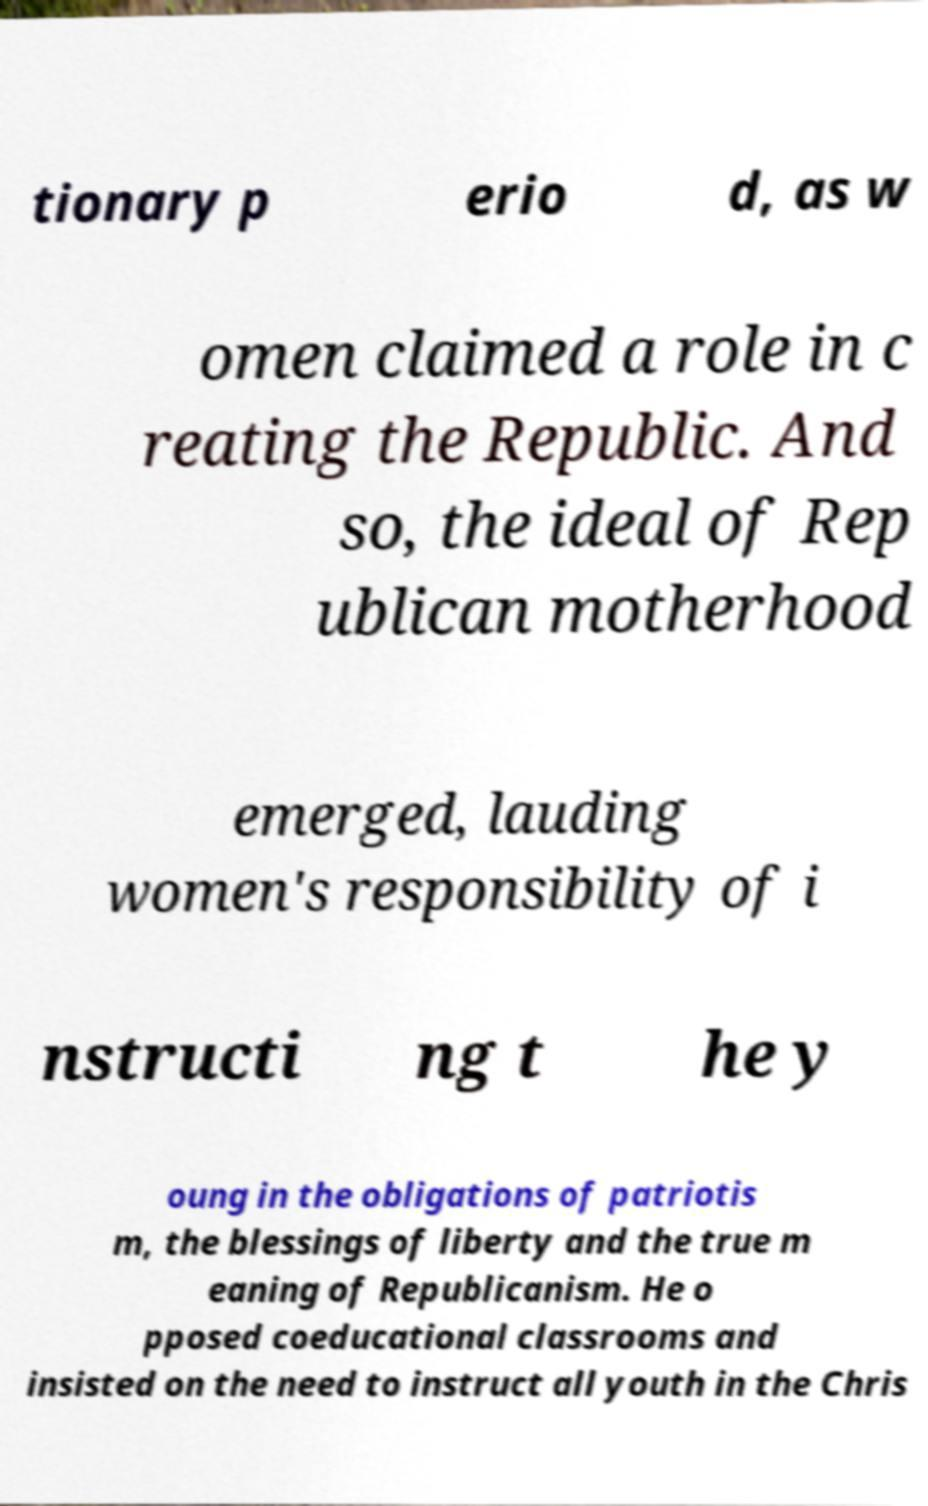Please identify and transcribe the text found in this image. tionary p erio d, as w omen claimed a role in c reating the Republic. And so, the ideal of Rep ublican motherhood emerged, lauding women's responsibility of i nstructi ng t he y oung in the obligations of patriotis m, the blessings of liberty and the true m eaning of Republicanism. He o pposed coeducational classrooms and insisted on the need to instruct all youth in the Chris 